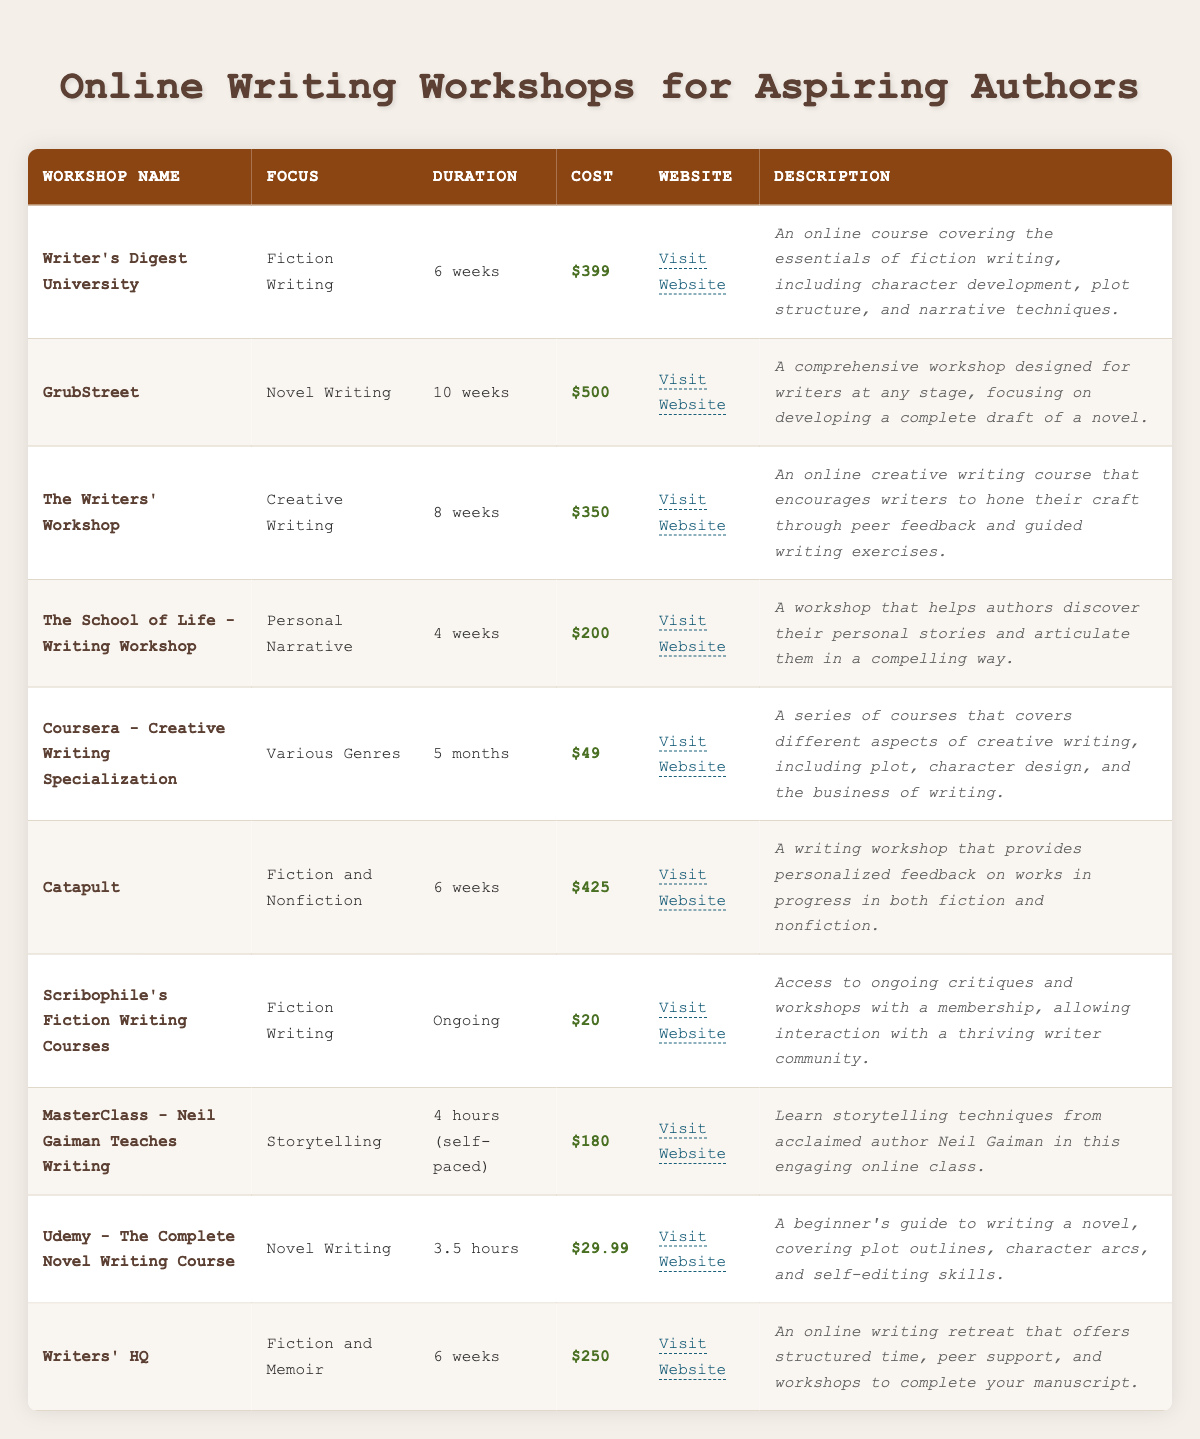What is the cost of GrubStreet workshop? The cost of GrubStreet is listed directly in the table under the "Cost" column, corresponding to the workshop name. It shows $500 next to GrubStreet.
Answer: $500 How long is the Coursera - Creative Writing Specialization? The duration of the Coursera - Creative Writing Specialization is found in the "Duration" column in the table. It states "5 months."
Answer: 5 months Which workshop offers the lowest cost? To determine which workshop has the lowest cost, we need to compare the costs listed for each workshop. The lowest cost from the table is Scribophile's Fiction Writing Courses at $20.
Answer: $20 What is the average cost of workshops focused on Novel Writing? First, identify which workshops focus on Novel Writing: GrubStreet ($500) and Udemy - The Complete Novel Writing Course ($29.99). Then, sum the costs: 500 + 29.99 = 529. There are 2 workshops, so the average is 529 / 2 = 264.50.
Answer: $264.50 Is there a workshop that offers a duration shorter than 4 weeks? All workshops have durations longer than 4 weeks, except for "The School of Life - Writing Workshop," which lasts for 4 weeks. Therefore, no workshop offers a duration shorter than 4 weeks.
Answer: No How many workshops focus on Creative Writing as a central theme? Check the "Focus" column for instances of "Creative Writing." The workshops that match this focus are The Writers' Workshop and Coursera - Creative Writing Specialization. Therefore, there are 2 workshops.
Answer: 2 Which workshop has the most extended duration, and what is its cost? To find the workshop with the most extended duration, sort by the "Duration" column. GrubStreet has the longest duration at 10 weeks, with a cost of $500.
Answer: GrubStreet, $500 What is the difference in cost between the most expensive and the least expensive workshop? The most expensive workshop is GrubStreet at $500, and the least expensive is Scribophile's Fiction Writing Courses at $20. The difference is calculated as 500 - 20 = 480.
Answer: $480 Are there any workshops that focus specifically on Personal Narrative? Yes, "The School of Life - Writing Workshop" focuses specifically on Personal Narrative according to the "Focus" column in the workshop list.
Answer: Yes 